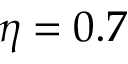Convert formula to latex. <formula><loc_0><loc_0><loc_500><loc_500>\eta = 0 . 7</formula> 